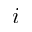<formula> <loc_0><loc_0><loc_500><loc_500>i</formula> 